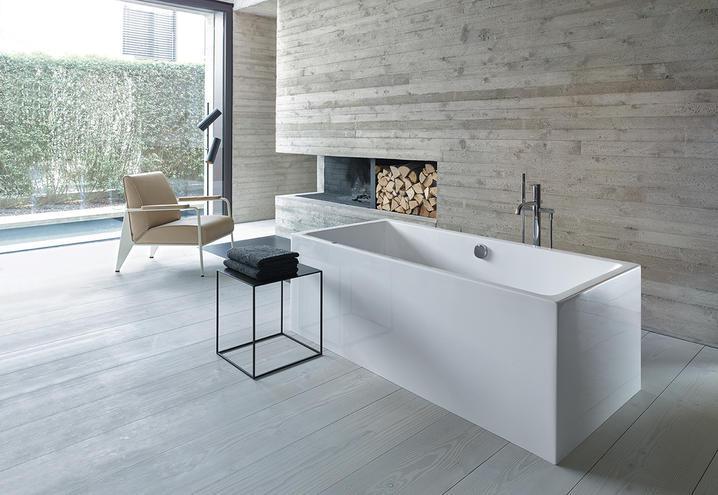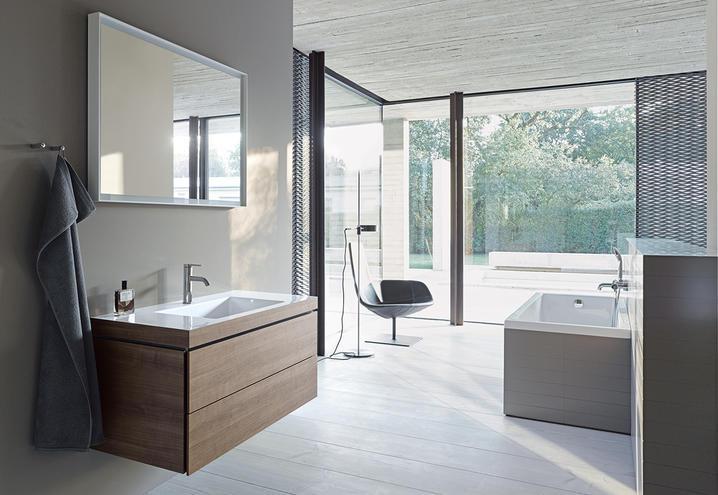The first image is the image on the left, the second image is the image on the right. Analyze the images presented: Is the assertion "In the image to the right, we have a bathtub." valid? Answer yes or no. Yes. 